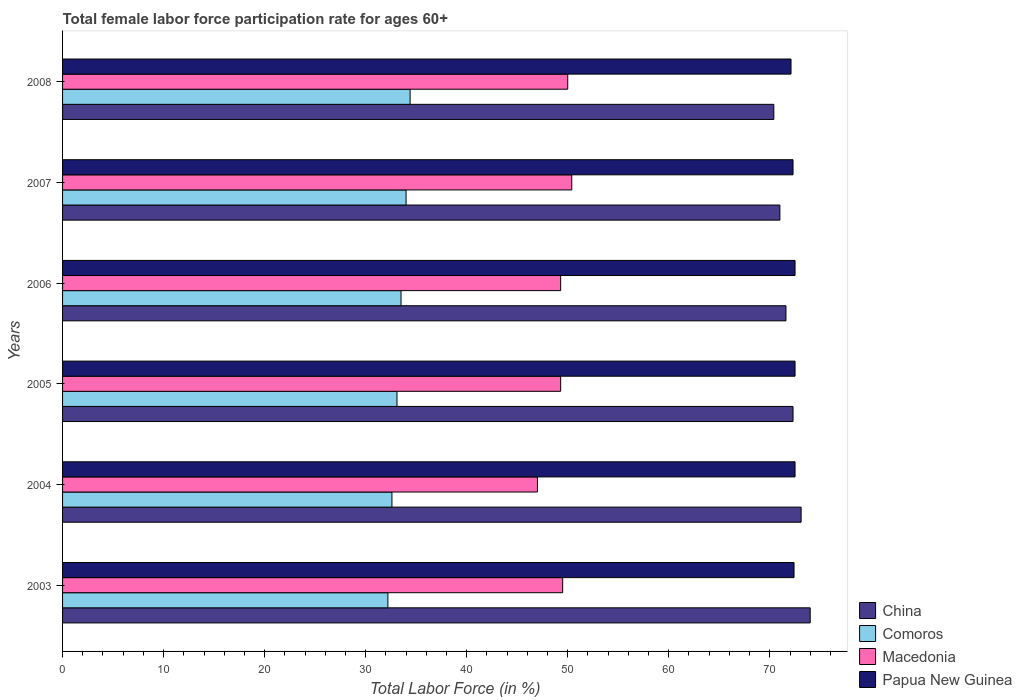How many different coloured bars are there?
Give a very brief answer. 4. How many groups of bars are there?
Your answer should be very brief. 6. How many bars are there on the 3rd tick from the bottom?
Your answer should be very brief. 4. What is the label of the 3rd group of bars from the top?
Give a very brief answer. 2006. What is the female labor force participation rate in China in 2005?
Make the answer very short. 72.3. Across all years, what is the maximum female labor force participation rate in Macedonia?
Offer a very short reply. 50.4. Across all years, what is the minimum female labor force participation rate in Comoros?
Provide a short and direct response. 32.2. In which year was the female labor force participation rate in Macedonia maximum?
Provide a succinct answer. 2007. What is the total female labor force participation rate in Macedonia in the graph?
Ensure brevity in your answer.  295.5. What is the difference between the female labor force participation rate in Comoros in 2004 and that in 2007?
Your answer should be very brief. -1.4. What is the difference between the female labor force participation rate in China in 2006 and the female labor force participation rate in Macedonia in 2005?
Your response must be concise. 22.3. What is the average female labor force participation rate in Papua New Guinea per year?
Your answer should be very brief. 72.38. In the year 2008, what is the difference between the female labor force participation rate in Papua New Guinea and female labor force participation rate in China?
Your response must be concise. 1.7. In how many years, is the female labor force participation rate in Macedonia greater than 24 %?
Give a very brief answer. 6. What is the ratio of the female labor force participation rate in Papua New Guinea in 2005 to that in 2008?
Give a very brief answer. 1.01. What is the difference between the highest and the second highest female labor force participation rate in Comoros?
Your response must be concise. 0.4. What is the difference between the highest and the lowest female labor force participation rate in Comoros?
Provide a short and direct response. 2.2. Is the sum of the female labor force participation rate in Papua New Guinea in 2003 and 2007 greater than the maximum female labor force participation rate in China across all years?
Give a very brief answer. Yes. What does the 3rd bar from the top in 2003 represents?
Offer a very short reply. Comoros. What does the 4th bar from the bottom in 2006 represents?
Your response must be concise. Papua New Guinea. How many bars are there?
Your answer should be compact. 24. Are all the bars in the graph horizontal?
Offer a terse response. Yes. How many years are there in the graph?
Provide a short and direct response. 6. Does the graph contain any zero values?
Offer a terse response. No. Where does the legend appear in the graph?
Offer a terse response. Bottom right. How many legend labels are there?
Your answer should be very brief. 4. What is the title of the graph?
Offer a very short reply. Total female labor force participation rate for ages 60+. What is the label or title of the Y-axis?
Offer a terse response. Years. What is the Total Labor Force (in %) in Comoros in 2003?
Ensure brevity in your answer.  32.2. What is the Total Labor Force (in %) of Macedonia in 2003?
Make the answer very short. 49.5. What is the Total Labor Force (in %) in Papua New Guinea in 2003?
Keep it short and to the point. 72.4. What is the Total Labor Force (in %) in China in 2004?
Provide a short and direct response. 73.1. What is the Total Labor Force (in %) in Comoros in 2004?
Your answer should be very brief. 32.6. What is the Total Labor Force (in %) in Macedonia in 2004?
Ensure brevity in your answer.  47. What is the Total Labor Force (in %) of Papua New Guinea in 2004?
Keep it short and to the point. 72.5. What is the Total Labor Force (in %) of China in 2005?
Give a very brief answer. 72.3. What is the Total Labor Force (in %) of Comoros in 2005?
Your answer should be compact. 33.1. What is the Total Labor Force (in %) of Macedonia in 2005?
Give a very brief answer. 49.3. What is the Total Labor Force (in %) of Papua New Guinea in 2005?
Give a very brief answer. 72.5. What is the Total Labor Force (in %) in China in 2006?
Give a very brief answer. 71.6. What is the Total Labor Force (in %) of Comoros in 2006?
Your answer should be compact. 33.5. What is the Total Labor Force (in %) in Macedonia in 2006?
Offer a terse response. 49.3. What is the Total Labor Force (in %) in Papua New Guinea in 2006?
Offer a terse response. 72.5. What is the Total Labor Force (in %) in Macedonia in 2007?
Offer a very short reply. 50.4. What is the Total Labor Force (in %) of Papua New Guinea in 2007?
Offer a terse response. 72.3. What is the Total Labor Force (in %) in China in 2008?
Offer a very short reply. 70.4. What is the Total Labor Force (in %) of Comoros in 2008?
Provide a short and direct response. 34.4. What is the Total Labor Force (in %) of Macedonia in 2008?
Offer a terse response. 50. What is the Total Labor Force (in %) of Papua New Guinea in 2008?
Keep it short and to the point. 72.1. Across all years, what is the maximum Total Labor Force (in %) of China?
Ensure brevity in your answer.  74. Across all years, what is the maximum Total Labor Force (in %) of Comoros?
Keep it short and to the point. 34.4. Across all years, what is the maximum Total Labor Force (in %) in Macedonia?
Make the answer very short. 50.4. Across all years, what is the maximum Total Labor Force (in %) of Papua New Guinea?
Your answer should be very brief. 72.5. Across all years, what is the minimum Total Labor Force (in %) of China?
Ensure brevity in your answer.  70.4. Across all years, what is the minimum Total Labor Force (in %) in Comoros?
Give a very brief answer. 32.2. Across all years, what is the minimum Total Labor Force (in %) in Macedonia?
Give a very brief answer. 47. Across all years, what is the minimum Total Labor Force (in %) of Papua New Guinea?
Provide a succinct answer. 72.1. What is the total Total Labor Force (in %) of China in the graph?
Ensure brevity in your answer.  432.4. What is the total Total Labor Force (in %) of Comoros in the graph?
Your answer should be very brief. 199.8. What is the total Total Labor Force (in %) of Macedonia in the graph?
Make the answer very short. 295.5. What is the total Total Labor Force (in %) of Papua New Guinea in the graph?
Offer a terse response. 434.3. What is the difference between the Total Labor Force (in %) of China in 2003 and that in 2004?
Ensure brevity in your answer.  0.9. What is the difference between the Total Labor Force (in %) in Macedonia in 2003 and that in 2004?
Offer a terse response. 2.5. What is the difference between the Total Labor Force (in %) in Papua New Guinea in 2003 and that in 2004?
Give a very brief answer. -0.1. What is the difference between the Total Labor Force (in %) of Comoros in 2003 and that in 2005?
Provide a succinct answer. -0.9. What is the difference between the Total Labor Force (in %) in China in 2003 and that in 2006?
Your answer should be compact. 2.4. What is the difference between the Total Labor Force (in %) of Comoros in 2003 and that in 2006?
Your answer should be very brief. -1.3. What is the difference between the Total Labor Force (in %) in China in 2003 and that in 2007?
Make the answer very short. 3. What is the difference between the Total Labor Force (in %) in Macedonia in 2003 and that in 2007?
Your answer should be compact. -0.9. What is the difference between the Total Labor Force (in %) in Comoros in 2003 and that in 2008?
Make the answer very short. -2.2. What is the difference between the Total Labor Force (in %) in Macedonia in 2003 and that in 2008?
Offer a terse response. -0.5. What is the difference between the Total Labor Force (in %) of Papua New Guinea in 2003 and that in 2008?
Ensure brevity in your answer.  0.3. What is the difference between the Total Labor Force (in %) of China in 2004 and that in 2005?
Offer a terse response. 0.8. What is the difference between the Total Labor Force (in %) of Macedonia in 2004 and that in 2005?
Your answer should be compact. -2.3. What is the difference between the Total Labor Force (in %) in China in 2004 and that in 2006?
Your response must be concise. 1.5. What is the difference between the Total Labor Force (in %) in China in 2004 and that in 2007?
Ensure brevity in your answer.  2.1. What is the difference between the Total Labor Force (in %) in Comoros in 2004 and that in 2007?
Ensure brevity in your answer.  -1.4. What is the difference between the Total Labor Force (in %) of Comoros in 2004 and that in 2008?
Give a very brief answer. -1.8. What is the difference between the Total Labor Force (in %) in Macedonia in 2004 and that in 2008?
Offer a terse response. -3. What is the difference between the Total Labor Force (in %) in Comoros in 2005 and that in 2006?
Your response must be concise. -0.4. What is the difference between the Total Labor Force (in %) in Macedonia in 2005 and that in 2006?
Ensure brevity in your answer.  0. What is the difference between the Total Labor Force (in %) in China in 2005 and that in 2007?
Ensure brevity in your answer.  1.3. What is the difference between the Total Labor Force (in %) of Comoros in 2005 and that in 2007?
Provide a succinct answer. -0.9. What is the difference between the Total Labor Force (in %) in Macedonia in 2005 and that in 2007?
Provide a short and direct response. -1.1. What is the difference between the Total Labor Force (in %) of Papua New Guinea in 2005 and that in 2007?
Give a very brief answer. 0.2. What is the difference between the Total Labor Force (in %) in China in 2005 and that in 2008?
Your answer should be compact. 1.9. What is the difference between the Total Labor Force (in %) of Papua New Guinea in 2005 and that in 2008?
Give a very brief answer. 0.4. What is the difference between the Total Labor Force (in %) of Comoros in 2006 and that in 2007?
Give a very brief answer. -0.5. What is the difference between the Total Labor Force (in %) of Papua New Guinea in 2006 and that in 2007?
Offer a terse response. 0.2. What is the difference between the Total Labor Force (in %) of China in 2006 and that in 2008?
Ensure brevity in your answer.  1.2. What is the difference between the Total Labor Force (in %) of Comoros in 2006 and that in 2008?
Ensure brevity in your answer.  -0.9. What is the difference between the Total Labor Force (in %) in Macedonia in 2006 and that in 2008?
Give a very brief answer. -0.7. What is the difference between the Total Labor Force (in %) of Papua New Guinea in 2006 and that in 2008?
Your response must be concise. 0.4. What is the difference between the Total Labor Force (in %) in Papua New Guinea in 2007 and that in 2008?
Ensure brevity in your answer.  0.2. What is the difference between the Total Labor Force (in %) of China in 2003 and the Total Labor Force (in %) of Comoros in 2004?
Your response must be concise. 41.4. What is the difference between the Total Labor Force (in %) of Comoros in 2003 and the Total Labor Force (in %) of Macedonia in 2004?
Keep it short and to the point. -14.8. What is the difference between the Total Labor Force (in %) in Comoros in 2003 and the Total Labor Force (in %) in Papua New Guinea in 2004?
Give a very brief answer. -40.3. What is the difference between the Total Labor Force (in %) in Macedonia in 2003 and the Total Labor Force (in %) in Papua New Guinea in 2004?
Your answer should be very brief. -23. What is the difference between the Total Labor Force (in %) in China in 2003 and the Total Labor Force (in %) in Comoros in 2005?
Provide a succinct answer. 40.9. What is the difference between the Total Labor Force (in %) in China in 2003 and the Total Labor Force (in %) in Macedonia in 2005?
Offer a terse response. 24.7. What is the difference between the Total Labor Force (in %) in China in 2003 and the Total Labor Force (in %) in Papua New Guinea in 2005?
Your answer should be compact. 1.5. What is the difference between the Total Labor Force (in %) in Comoros in 2003 and the Total Labor Force (in %) in Macedonia in 2005?
Ensure brevity in your answer.  -17.1. What is the difference between the Total Labor Force (in %) in Comoros in 2003 and the Total Labor Force (in %) in Papua New Guinea in 2005?
Your response must be concise. -40.3. What is the difference between the Total Labor Force (in %) of Macedonia in 2003 and the Total Labor Force (in %) of Papua New Guinea in 2005?
Provide a succinct answer. -23. What is the difference between the Total Labor Force (in %) of China in 2003 and the Total Labor Force (in %) of Comoros in 2006?
Make the answer very short. 40.5. What is the difference between the Total Labor Force (in %) in China in 2003 and the Total Labor Force (in %) in Macedonia in 2006?
Ensure brevity in your answer.  24.7. What is the difference between the Total Labor Force (in %) in Comoros in 2003 and the Total Labor Force (in %) in Macedonia in 2006?
Make the answer very short. -17.1. What is the difference between the Total Labor Force (in %) of Comoros in 2003 and the Total Labor Force (in %) of Papua New Guinea in 2006?
Your answer should be compact. -40.3. What is the difference between the Total Labor Force (in %) in Macedonia in 2003 and the Total Labor Force (in %) in Papua New Guinea in 2006?
Your response must be concise. -23. What is the difference between the Total Labor Force (in %) in China in 2003 and the Total Labor Force (in %) in Comoros in 2007?
Ensure brevity in your answer.  40. What is the difference between the Total Labor Force (in %) of China in 2003 and the Total Labor Force (in %) of Macedonia in 2007?
Provide a short and direct response. 23.6. What is the difference between the Total Labor Force (in %) of Comoros in 2003 and the Total Labor Force (in %) of Macedonia in 2007?
Ensure brevity in your answer.  -18.2. What is the difference between the Total Labor Force (in %) of Comoros in 2003 and the Total Labor Force (in %) of Papua New Guinea in 2007?
Provide a short and direct response. -40.1. What is the difference between the Total Labor Force (in %) in Macedonia in 2003 and the Total Labor Force (in %) in Papua New Guinea in 2007?
Your answer should be compact. -22.8. What is the difference between the Total Labor Force (in %) of China in 2003 and the Total Labor Force (in %) of Comoros in 2008?
Your answer should be compact. 39.6. What is the difference between the Total Labor Force (in %) in China in 2003 and the Total Labor Force (in %) in Papua New Guinea in 2008?
Give a very brief answer. 1.9. What is the difference between the Total Labor Force (in %) in Comoros in 2003 and the Total Labor Force (in %) in Macedonia in 2008?
Your answer should be compact. -17.8. What is the difference between the Total Labor Force (in %) in Comoros in 2003 and the Total Labor Force (in %) in Papua New Guinea in 2008?
Ensure brevity in your answer.  -39.9. What is the difference between the Total Labor Force (in %) in Macedonia in 2003 and the Total Labor Force (in %) in Papua New Guinea in 2008?
Make the answer very short. -22.6. What is the difference between the Total Labor Force (in %) in China in 2004 and the Total Labor Force (in %) in Macedonia in 2005?
Make the answer very short. 23.8. What is the difference between the Total Labor Force (in %) of China in 2004 and the Total Labor Force (in %) of Papua New Guinea in 2005?
Provide a short and direct response. 0.6. What is the difference between the Total Labor Force (in %) in Comoros in 2004 and the Total Labor Force (in %) in Macedonia in 2005?
Your response must be concise. -16.7. What is the difference between the Total Labor Force (in %) in Comoros in 2004 and the Total Labor Force (in %) in Papua New Guinea in 2005?
Provide a succinct answer. -39.9. What is the difference between the Total Labor Force (in %) in Macedonia in 2004 and the Total Labor Force (in %) in Papua New Guinea in 2005?
Your response must be concise. -25.5. What is the difference between the Total Labor Force (in %) in China in 2004 and the Total Labor Force (in %) in Comoros in 2006?
Your answer should be compact. 39.6. What is the difference between the Total Labor Force (in %) of China in 2004 and the Total Labor Force (in %) of Macedonia in 2006?
Make the answer very short. 23.8. What is the difference between the Total Labor Force (in %) of China in 2004 and the Total Labor Force (in %) of Papua New Guinea in 2006?
Offer a very short reply. 0.6. What is the difference between the Total Labor Force (in %) in Comoros in 2004 and the Total Labor Force (in %) in Macedonia in 2006?
Offer a very short reply. -16.7. What is the difference between the Total Labor Force (in %) in Comoros in 2004 and the Total Labor Force (in %) in Papua New Guinea in 2006?
Give a very brief answer. -39.9. What is the difference between the Total Labor Force (in %) of Macedonia in 2004 and the Total Labor Force (in %) of Papua New Guinea in 2006?
Offer a terse response. -25.5. What is the difference between the Total Labor Force (in %) of China in 2004 and the Total Labor Force (in %) of Comoros in 2007?
Offer a terse response. 39.1. What is the difference between the Total Labor Force (in %) of China in 2004 and the Total Labor Force (in %) of Macedonia in 2007?
Provide a short and direct response. 22.7. What is the difference between the Total Labor Force (in %) of China in 2004 and the Total Labor Force (in %) of Papua New Guinea in 2007?
Your answer should be compact. 0.8. What is the difference between the Total Labor Force (in %) of Comoros in 2004 and the Total Labor Force (in %) of Macedonia in 2007?
Keep it short and to the point. -17.8. What is the difference between the Total Labor Force (in %) in Comoros in 2004 and the Total Labor Force (in %) in Papua New Guinea in 2007?
Offer a very short reply. -39.7. What is the difference between the Total Labor Force (in %) of Macedonia in 2004 and the Total Labor Force (in %) of Papua New Guinea in 2007?
Your answer should be very brief. -25.3. What is the difference between the Total Labor Force (in %) of China in 2004 and the Total Labor Force (in %) of Comoros in 2008?
Your answer should be compact. 38.7. What is the difference between the Total Labor Force (in %) in China in 2004 and the Total Labor Force (in %) in Macedonia in 2008?
Your answer should be very brief. 23.1. What is the difference between the Total Labor Force (in %) in Comoros in 2004 and the Total Labor Force (in %) in Macedonia in 2008?
Provide a succinct answer. -17.4. What is the difference between the Total Labor Force (in %) in Comoros in 2004 and the Total Labor Force (in %) in Papua New Guinea in 2008?
Give a very brief answer. -39.5. What is the difference between the Total Labor Force (in %) of Macedonia in 2004 and the Total Labor Force (in %) of Papua New Guinea in 2008?
Give a very brief answer. -25.1. What is the difference between the Total Labor Force (in %) in China in 2005 and the Total Labor Force (in %) in Comoros in 2006?
Your answer should be very brief. 38.8. What is the difference between the Total Labor Force (in %) in Comoros in 2005 and the Total Labor Force (in %) in Macedonia in 2006?
Make the answer very short. -16.2. What is the difference between the Total Labor Force (in %) in Comoros in 2005 and the Total Labor Force (in %) in Papua New Guinea in 2006?
Your answer should be very brief. -39.4. What is the difference between the Total Labor Force (in %) of Macedonia in 2005 and the Total Labor Force (in %) of Papua New Guinea in 2006?
Make the answer very short. -23.2. What is the difference between the Total Labor Force (in %) of China in 2005 and the Total Labor Force (in %) of Comoros in 2007?
Your response must be concise. 38.3. What is the difference between the Total Labor Force (in %) in China in 2005 and the Total Labor Force (in %) in Macedonia in 2007?
Your response must be concise. 21.9. What is the difference between the Total Labor Force (in %) in Comoros in 2005 and the Total Labor Force (in %) in Macedonia in 2007?
Provide a short and direct response. -17.3. What is the difference between the Total Labor Force (in %) of Comoros in 2005 and the Total Labor Force (in %) of Papua New Guinea in 2007?
Offer a very short reply. -39.2. What is the difference between the Total Labor Force (in %) of China in 2005 and the Total Labor Force (in %) of Comoros in 2008?
Your answer should be compact. 37.9. What is the difference between the Total Labor Force (in %) of China in 2005 and the Total Labor Force (in %) of Macedonia in 2008?
Ensure brevity in your answer.  22.3. What is the difference between the Total Labor Force (in %) in China in 2005 and the Total Labor Force (in %) in Papua New Guinea in 2008?
Make the answer very short. 0.2. What is the difference between the Total Labor Force (in %) in Comoros in 2005 and the Total Labor Force (in %) in Macedonia in 2008?
Your response must be concise. -16.9. What is the difference between the Total Labor Force (in %) of Comoros in 2005 and the Total Labor Force (in %) of Papua New Guinea in 2008?
Provide a short and direct response. -39. What is the difference between the Total Labor Force (in %) in Macedonia in 2005 and the Total Labor Force (in %) in Papua New Guinea in 2008?
Provide a succinct answer. -22.8. What is the difference between the Total Labor Force (in %) of China in 2006 and the Total Labor Force (in %) of Comoros in 2007?
Make the answer very short. 37.6. What is the difference between the Total Labor Force (in %) of China in 2006 and the Total Labor Force (in %) of Macedonia in 2007?
Provide a succinct answer. 21.2. What is the difference between the Total Labor Force (in %) of Comoros in 2006 and the Total Labor Force (in %) of Macedonia in 2007?
Ensure brevity in your answer.  -16.9. What is the difference between the Total Labor Force (in %) in Comoros in 2006 and the Total Labor Force (in %) in Papua New Guinea in 2007?
Make the answer very short. -38.8. What is the difference between the Total Labor Force (in %) of Macedonia in 2006 and the Total Labor Force (in %) of Papua New Guinea in 2007?
Your answer should be compact. -23. What is the difference between the Total Labor Force (in %) of China in 2006 and the Total Labor Force (in %) of Comoros in 2008?
Offer a very short reply. 37.2. What is the difference between the Total Labor Force (in %) in China in 2006 and the Total Labor Force (in %) in Macedonia in 2008?
Provide a short and direct response. 21.6. What is the difference between the Total Labor Force (in %) of China in 2006 and the Total Labor Force (in %) of Papua New Guinea in 2008?
Give a very brief answer. -0.5. What is the difference between the Total Labor Force (in %) of Comoros in 2006 and the Total Labor Force (in %) of Macedonia in 2008?
Offer a very short reply. -16.5. What is the difference between the Total Labor Force (in %) of Comoros in 2006 and the Total Labor Force (in %) of Papua New Guinea in 2008?
Keep it short and to the point. -38.6. What is the difference between the Total Labor Force (in %) in Macedonia in 2006 and the Total Labor Force (in %) in Papua New Guinea in 2008?
Provide a succinct answer. -22.8. What is the difference between the Total Labor Force (in %) of China in 2007 and the Total Labor Force (in %) of Comoros in 2008?
Offer a very short reply. 36.6. What is the difference between the Total Labor Force (in %) of China in 2007 and the Total Labor Force (in %) of Macedonia in 2008?
Your answer should be compact. 21. What is the difference between the Total Labor Force (in %) of Comoros in 2007 and the Total Labor Force (in %) of Papua New Guinea in 2008?
Offer a very short reply. -38.1. What is the difference between the Total Labor Force (in %) in Macedonia in 2007 and the Total Labor Force (in %) in Papua New Guinea in 2008?
Offer a very short reply. -21.7. What is the average Total Labor Force (in %) in China per year?
Keep it short and to the point. 72.07. What is the average Total Labor Force (in %) of Comoros per year?
Make the answer very short. 33.3. What is the average Total Labor Force (in %) of Macedonia per year?
Offer a very short reply. 49.25. What is the average Total Labor Force (in %) in Papua New Guinea per year?
Offer a terse response. 72.38. In the year 2003, what is the difference between the Total Labor Force (in %) of China and Total Labor Force (in %) of Comoros?
Your answer should be very brief. 41.8. In the year 2003, what is the difference between the Total Labor Force (in %) of China and Total Labor Force (in %) of Macedonia?
Provide a succinct answer. 24.5. In the year 2003, what is the difference between the Total Labor Force (in %) in Comoros and Total Labor Force (in %) in Macedonia?
Ensure brevity in your answer.  -17.3. In the year 2003, what is the difference between the Total Labor Force (in %) of Comoros and Total Labor Force (in %) of Papua New Guinea?
Ensure brevity in your answer.  -40.2. In the year 2003, what is the difference between the Total Labor Force (in %) in Macedonia and Total Labor Force (in %) in Papua New Guinea?
Your answer should be compact. -22.9. In the year 2004, what is the difference between the Total Labor Force (in %) in China and Total Labor Force (in %) in Comoros?
Offer a terse response. 40.5. In the year 2004, what is the difference between the Total Labor Force (in %) in China and Total Labor Force (in %) in Macedonia?
Make the answer very short. 26.1. In the year 2004, what is the difference between the Total Labor Force (in %) in Comoros and Total Labor Force (in %) in Macedonia?
Your answer should be compact. -14.4. In the year 2004, what is the difference between the Total Labor Force (in %) in Comoros and Total Labor Force (in %) in Papua New Guinea?
Make the answer very short. -39.9. In the year 2004, what is the difference between the Total Labor Force (in %) in Macedonia and Total Labor Force (in %) in Papua New Guinea?
Your response must be concise. -25.5. In the year 2005, what is the difference between the Total Labor Force (in %) of China and Total Labor Force (in %) of Comoros?
Provide a short and direct response. 39.2. In the year 2005, what is the difference between the Total Labor Force (in %) of China and Total Labor Force (in %) of Macedonia?
Provide a short and direct response. 23. In the year 2005, what is the difference between the Total Labor Force (in %) of China and Total Labor Force (in %) of Papua New Guinea?
Keep it short and to the point. -0.2. In the year 2005, what is the difference between the Total Labor Force (in %) in Comoros and Total Labor Force (in %) in Macedonia?
Provide a short and direct response. -16.2. In the year 2005, what is the difference between the Total Labor Force (in %) of Comoros and Total Labor Force (in %) of Papua New Guinea?
Your answer should be very brief. -39.4. In the year 2005, what is the difference between the Total Labor Force (in %) of Macedonia and Total Labor Force (in %) of Papua New Guinea?
Ensure brevity in your answer.  -23.2. In the year 2006, what is the difference between the Total Labor Force (in %) of China and Total Labor Force (in %) of Comoros?
Offer a very short reply. 38.1. In the year 2006, what is the difference between the Total Labor Force (in %) in China and Total Labor Force (in %) in Macedonia?
Give a very brief answer. 22.3. In the year 2006, what is the difference between the Total Labor Force (in %) in China and Total Labor Force (in %) in Papua New Guinea?
Keep it short and to the point. -0.9. In the year 2006, what is the difference between the Total Labor Force (in %) in Comoros and Total Labor Force (in %) in Macedonia?
Provide a succinct answer. -15.8. In the year 2006, what is the difference between the Total Labor Force (in %) of Comoros and Total Labor Force (in %) of Papua New Guinea?
Give a very brief answer. -39. In the year 2006, what is the difference between the Total Labor Force (in %) of Macedonia and Total Labor Force (in %) of Papua New Guinea?
Ensure brevity in your answer.  -23.2. In the year 2007, what is the difference between the Total Labor Force (in %) in China and Total Labor Force (in %) in Macedonia?
Keep it short and to the point. 20.6. In the year 2007, what is the difference between the Total Labor Force (in %) of China and Total Labor Force (in %) of Papua New Guinea?
Your answer should be compact. -1.3. In the year 2007, what is the difference between the Total Labor Force (in %) of Comoros and Total Labor Force (in %) of Macedonia?
Keep it short and to the point. -16.4. In the year 2007, what is the difference between the Total Labor Force (in %) in Comoros and Total Labor Force (in %) in Papua New Guinea?
Offer a terse response. -38.3. In the year 2007, what is the difference between the Total Labor Force (in %) in Macedonia and Total Labor Force (in %) in Papua New Guinea?
Make the answer very short. -21.9. In the year 2008, what is the difference between the Total Labor Force (in %) of China and Total Labor Force (in %) of Macedonia?
Keep it short and to the point. 20.4. In the year 2008, what is the difference between the Total Labor Force (in %) of China and Total Labor Force (in %) of Papua New Guinea?
Ensure brevity in your answer.  -1.7. In the year 2008, what is the difference between the Total Labor Force (in %) in Comoros and Total Labor Force (in %) in Macedonia?
Your response must be concise. -15.6. In the year 2008, what is the difference between the Total Labor Force (in %) of Comoros and Total Labor Force (in %) of Papua New Guinea?
Your answer should be very brief. -37.7. In the year 2008, what is the difference between the Total Labor Force (in %) of Macedonia and Total Labor Force (in %) of Papua New Guinea?
Offer a terse response. -22.1. What is the ratio of the Total Labor Force (in %) in China in 2003 to that in 2004?
Your answer should be compact. 1.01. What is the ratio of the Total Labor Force (in %) of Macedonia in 2003 to that in 2004?
Your answer should be very brief. 1.05. What is the ratio of the Total Labor Force (in %) of Papua New Guinea in 2003 to that in 2004?
Keep it short and to the point. 1. What is the ratio of the Total Labor Force (in %) in China in 2003 to that in 2005?
Offer a terse response. 1.02. What is the ratio of the Total Labor Force (in %) of Comoros in 2003 to that in 2005?
Your answer should be compact. 0.97. What is the ratio of the Total Labor Force (in %) of China in 2003 to that in 2006?
Provide a succinct answer. 1.03. What is the ratio of the Total Labor Force (in %) in Comoros in 2003 to that in 2006?
Provide a succinct answer. 0.96. What is the ratio of the Total Labor Force (in %) of Papua New Guinea in 2003 to that in 2006?
Give a very brief answer. 1. What is the ratio of the Total Labor Force (in %) of China in 2003 to that in 2007?
Your response must be concise. 1.04. What is the ratio of the Total Labor Force (in %) of Comoros in 2003 to that in 2007?
Provide a short and direct response. 0.95. What is the ratio of the Total Labor Force (in %) in Macedonia in 2003 to that in 2007?
Your response must be concise. 0.98. What is the ratio of the Total Labor Force (in %) of Papua New Guinea in 2003 to that in 2007?
Give a very brief answer. 1. What is the ratio of the Total Labor Force (in %) of China in 2003 to that in 2008?
Provide a succinct answer. 1.05. What is the ratio of the Total Labor Force (in %) in Comoros in 2003 to that in 2008?
Your answer should be very brief. 0.94. What is the ratio of the Total Labor Force (in %) of China in 2004 to that in 2005?
Keep it short and to the point. 1.01. What is the ratio of the Total Labor Force (in %) of Comoros in 2004 to that in 2005?
Make the answer very short. 0.98. What is the ratio of the Total Labor Force (in %) of Macedonia in 2004 to that in 2005?
Make the answer very short. 0.95. What is the ratio of the Total Labor Force (in %) in China in 2004 to that in 2006?
Your answer should be compact. 1.02. What is the ratio of the Total Labor Force (in %) of Comoros in 2004 to that in 2006?
Provide a short and direct response. 0.97. What is the ratio of the Total Labor Force (in %) of Macedonia in 2004 to that in 2006?
Your response must be concise. 0.95. What is the ratio of the Total Labor Force (in %) in China in 2004 to that in 2007?
Provide a succinct answer. 1.03. What is the ratio of the Total Labor Force (in %) in Comoros in 2004 to that in 2007?
Your answer should be compact. 0.96. What is the ratio of the Total Labor Force (in %) of Macedonia in 2004 to that in 2007?
Your answer should be very brief. 0.93. What is the ratio of the Total Labor Force (in %) of Papua New Guinea in 2004 to that in 2007?
Make the answer very short. 1. What is the ratio of the Total Labor Force (in %) of China in 2004 to that in 2008?
Make the answer very short. 1.04. What is the ratio of the Total Labor Force (in %) in Comoros in 2004 to that in 2008?
Offer a very short reply. 0.95. What is the ratio of the Total Labor Force (in %) of Macedonia in 2004 to that in 2008?
Your response must be concise. 0.94. What is the ratio of the Total Labor Force (in %) in China in 2005 to that in 2006?
Your response must be concise. 1.01. What is the ratio of the Total Labor Force (in %) in Macedonia in 2005 to that in 2006?
Make the answer very short. 1. What is the ratio of the Total Labor Force (in %) in Papua New Guinea in 2005 to that in 2006?
Your answer should be very brief. 1. What is the ratio of the Total Labor Force (in %) in China in 2005 to that in 2007?
Offer a terse response. 1.02. What is the ratio of the Total Labor Force (in %) of Comoros in 2005 to that in 2007?
Ensure brevity in your answer.  0.97. What is the ratio of the Total Labor Force (in %) of Macedonia in 2005 to that in 2007?
Give a very brief answer. 0.98. What is the ratio of the Total Labor Force (in %) of Papua New Guinea in 2005 to that in 2007?
Offer a very short reply. 1. What is the ratio of the Total Labor Force (in %) of China in 2005 to that in 2008?
Offer a very short reply. 1.03. What is the ratio of the Total Labor Force (in %) of Comoros in 2005 to that in 2008?
Offer a terse response. 0.96. What is the ratio of the Total Labor Force (in %) in Macedonia in 2005 to that in 2008?
Ensure brevity in your answer.  0.99. What is the ratio of the Total Labor Force (in %) of China in 2006 to that in 2007?
Keep it short and to the point. 1.01. What is the ratio of the Total Labor Force (in %) of Macedonia in 2006 to that in 2007?
Provide a short and direct response. 0.98. What is the ratio of the Total Labor Force (in %) in Comoros in 2006 to that in 2008?
Give a very brief answer. 0.97. What is the ratio of the Total Labor Force (in %) of Macedonia in 2006 to that in 2008?
Keep it short and to the point. 0.99. What is the ratio of the Total Labor Force (in %) of Papua New Guinea in 2006 to that in 2008?
Ensure brevity in your answer.  1.01. What is the ratio of the Total Labor Force (in %) in China in 2007 to that in 2008?
Keep it short and to the point. 1.01. What is the ratio of the Total Labor Force (in %) in Comoros in 2007 to that in 2008?
Offer a terse response. 0.99. What is the difference between the highest and the second highest Total Labor Force (in %) of China?
Provide a short and direct response. 0.9. What is the difference between the highest and the second highest Total Labor Force (in %) in Papua New Guinea?
Ensure brevity in your answer.  0. What is the difference between the highest and the lowest Total Labor Force (in %) of China?
Your answer should be compact. 3.6. What is the difference between the highest and the lowest Total Labor Force (in %) in Comoros?
Offer a very short reply. 2.2. What is the difference between the highest and the lowest Total Labor Force (in %) in Macedonia?
Provide a short and direct response. 3.4. 